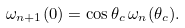<formula> <loc_0><loc_0><loc_500><loc_500>\omega _ { n + 1 } ( 0 ) = \cos \theta _ { c } \, \omega _ { n } ( \theta _ { c } ) .</formula> 